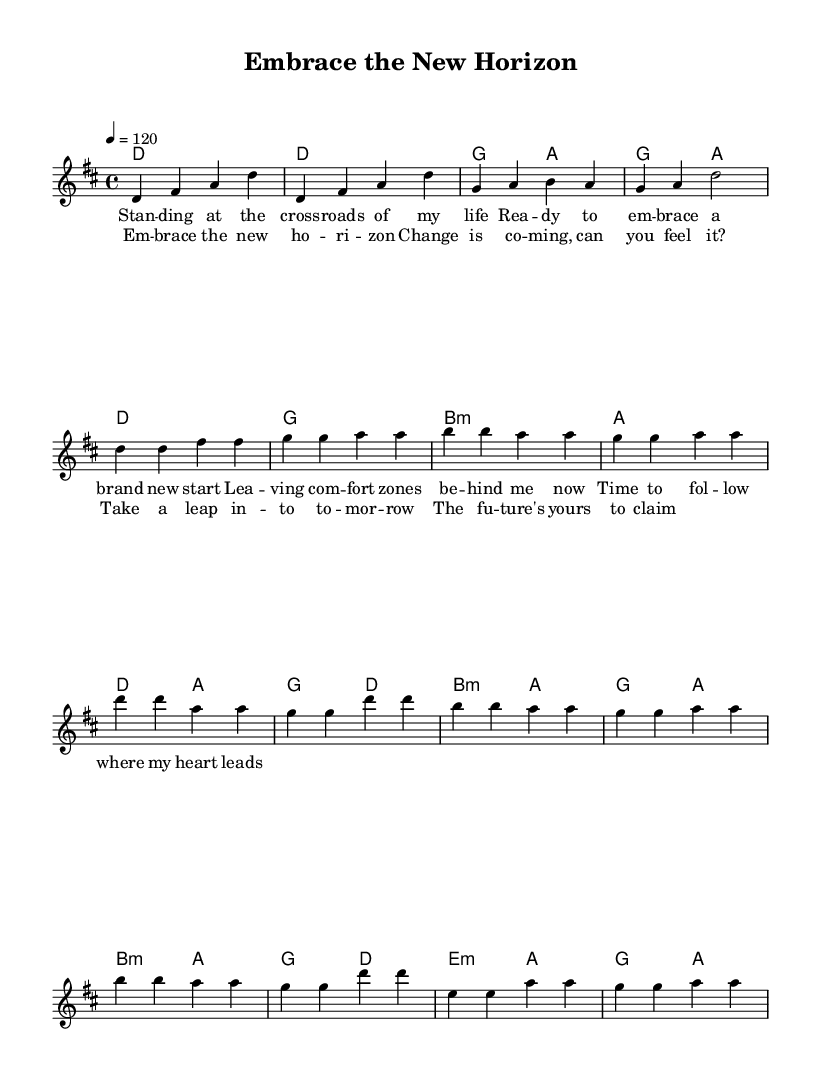What is the key signature of this music? The key signature is D major, which contains two sharps (F# and C#). This can be determined by looking at the key indicated at the beginning of the score, which states \key d \major.
Answer: D major What is the time signature of the piece? The time signature is 4/4, which means there are four beats in a measure and a quarter note receives one beat. This is clearly indicated in the score with the \time 4/4 notation.
Answer: 4/4 What is the tempo of the music? The tempo is marked at 120 beats per minute, indicated by \tempo 4 = 120. This means each quarter note is played at a speed of 120 beats in one minute.
Answer: 120 Which section follows the verse in the structure of this song? The section following the verse is the chorus. This is deduced from the layout of the song, where the verse is followed by a section labeled as chorus in the lyrics.
Answer: Chorus How many measures are in the intro? The intro consists of four measures. This can be counted directly from the notation presented in the score, where four distinct measures are laid out before transitioning to the verse.
Answer: 4 What is the highest note in the melody? The highest note in the melody is D, which occurs in a few places throughout the score but notably in the chorus section. This is observed by comparing all pitches in the melody to find the maximum.
Answer: D How many times is the phrase "Embrace the new horizon" repeated? The phrase is repeated once in the chorus, as seen in the lyric that appears there. Scanning through the lyrics of the chorus confirms that this exact phrase occurs in the section labeled chorus.
Answer: 1 